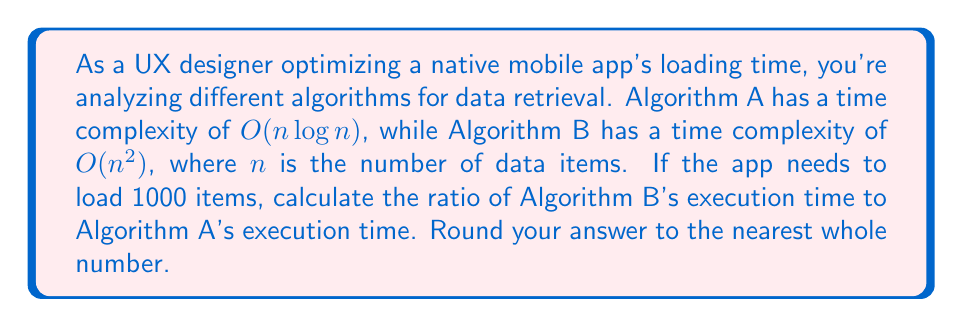Teach me how to tackle this problem. To solve this problem, we'll follow these steps:

1) First, let's recall the time complexities:
   Algorithm A: $O(n \log n)$
   Algorithm B: $O(n^2)$

2) We're given that $n = 1000$. Let's substitute this value:
   Algorithm A: $1000 \log 1000$
   Algorithm B: $1000^2$

3) Calculate $\log 1000$:
   $\log 1000 \approx 3$ (using base 10 logarithm)

4) Now we can calculate the approximate number of operations for each algorithm:
   Algorithm A: $1000 \cdot 3 = 3000$
   Algorithm B: $1000^2 = 1,000,000$

5) To find the ratio, we divide Algorithm B's time by Algorithm A's time:
   $\frac{1,000,000}{3000} \approx 333.33$

6) Rounding to the nearest whole number:
   $333.33 \approx 333$

Therefore, Algorithm B will take approximately 333 times longer than Algorithm A to execute for 1000 items.
Answer: 333 